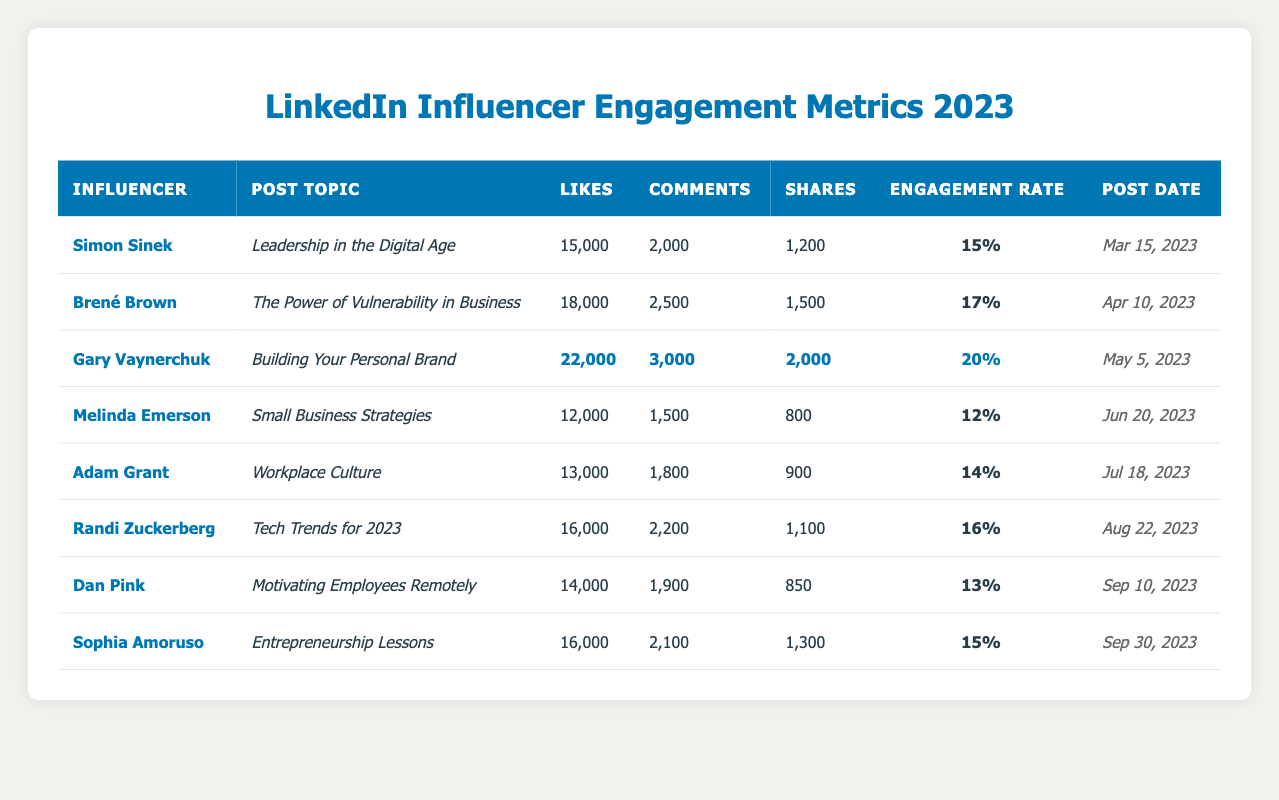What is the post topic of Gary Vaynerchuk's most engaging post? To find the post topic of Gary Vaynerchuk, locate his entry in the table. His most engaging post is about "Building Your Personal Brand," as indicated under the post topic column with the highest engagement metrics (likes, comments, shares).
Answer: Building Your Personal Brand Which influencer received the highest number of likes, and how many did they get? By scanning through the likes column, Gary Vaynerchuk has the highest likes at 22,000 among all influencers listed in the table.
Answer: Gary Vaynerchuk, 22000 What is the engagement rate of Melinda Emerson's post? Melinda Emerson's engagement rate can be found directly in the engagement rate column for her post, which shows a rate of 12%.
Answer: 12% What is the average number of comments across all posts? To find the average number of comments, sum the comments (2,000 + 2,500 + 3,000 + 1,500 + 1,800 + 2,200 + 1,900 + 2,100 = 16,200) and divide by the number of posts (8): 16,200 / 8 = 2,025.
Answer: 2025 Which influencer has the lowest engagement rate, and what is that rate? By comparing the engagement rates in the engagement rate column, Melinda Emerson has the lowest engagement rate at 12%.
Answer: Melinda Emerson, 12% If we combine the likes and shares of Dan Pink's post, what total do we get? Dan Pink's likes are 14,000 and shares are 850. Adding these together gives 14,000 + 850 = 14,850.
Answer: 14850 Is the engagement rate of Adam Grant's post higher than that of Randi Zuckerberg's post? Adam Grant's engagement rate is 14%, while Randi Zuckerberg's is 16%. Since 14% is less than 16%, the statement is false.
Answer: No How many total likes did Simon Sinek and Adam Grant receive for their posts combined? Simon Sinek received 15,000 likes and Adam Grant received 13,000 likes. Adding these gives a total of 15,000 + 13,000 = 28,000 likes.
Answer: 28000 What is the difference in the number of shares between Gary Vaynerchuk and Melinda Emerson? Gary Vaynerchuk has 2,000 shares and Melinda Emerson has 800 shares. The difference is 2,000 - 800 = 1,200 shares.
Answer: 1200 Which post received the most comments, and how many comments did it receive? Upon reviewing the comments column, Gary Vaynerchuk's post has the highest comments at 3,000.
Answer: Building Your Personal Brand, 3000 